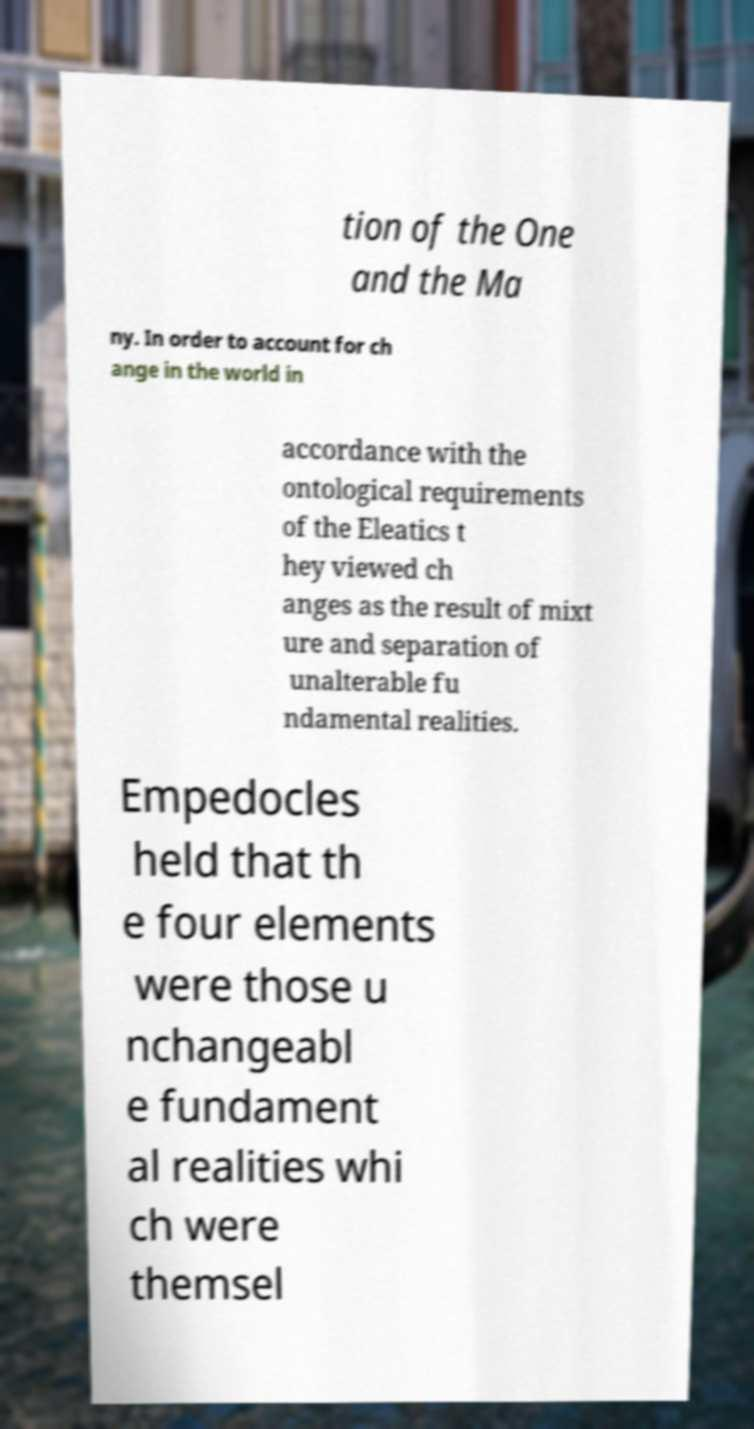There's text embedded in this image that I need extracted. Can you transcribe it verbatim? tion of the One and the Ma ny. In order to account for ch ange in the world in accordance with the ontological requirements of the Eleatics t hey viewed ch anges as the result of mixt ure and separation of unalterable fu ndamental realities. Empedocles held that th e four elements were those u nchangeabl e fundament al realities whi ch were themsel 